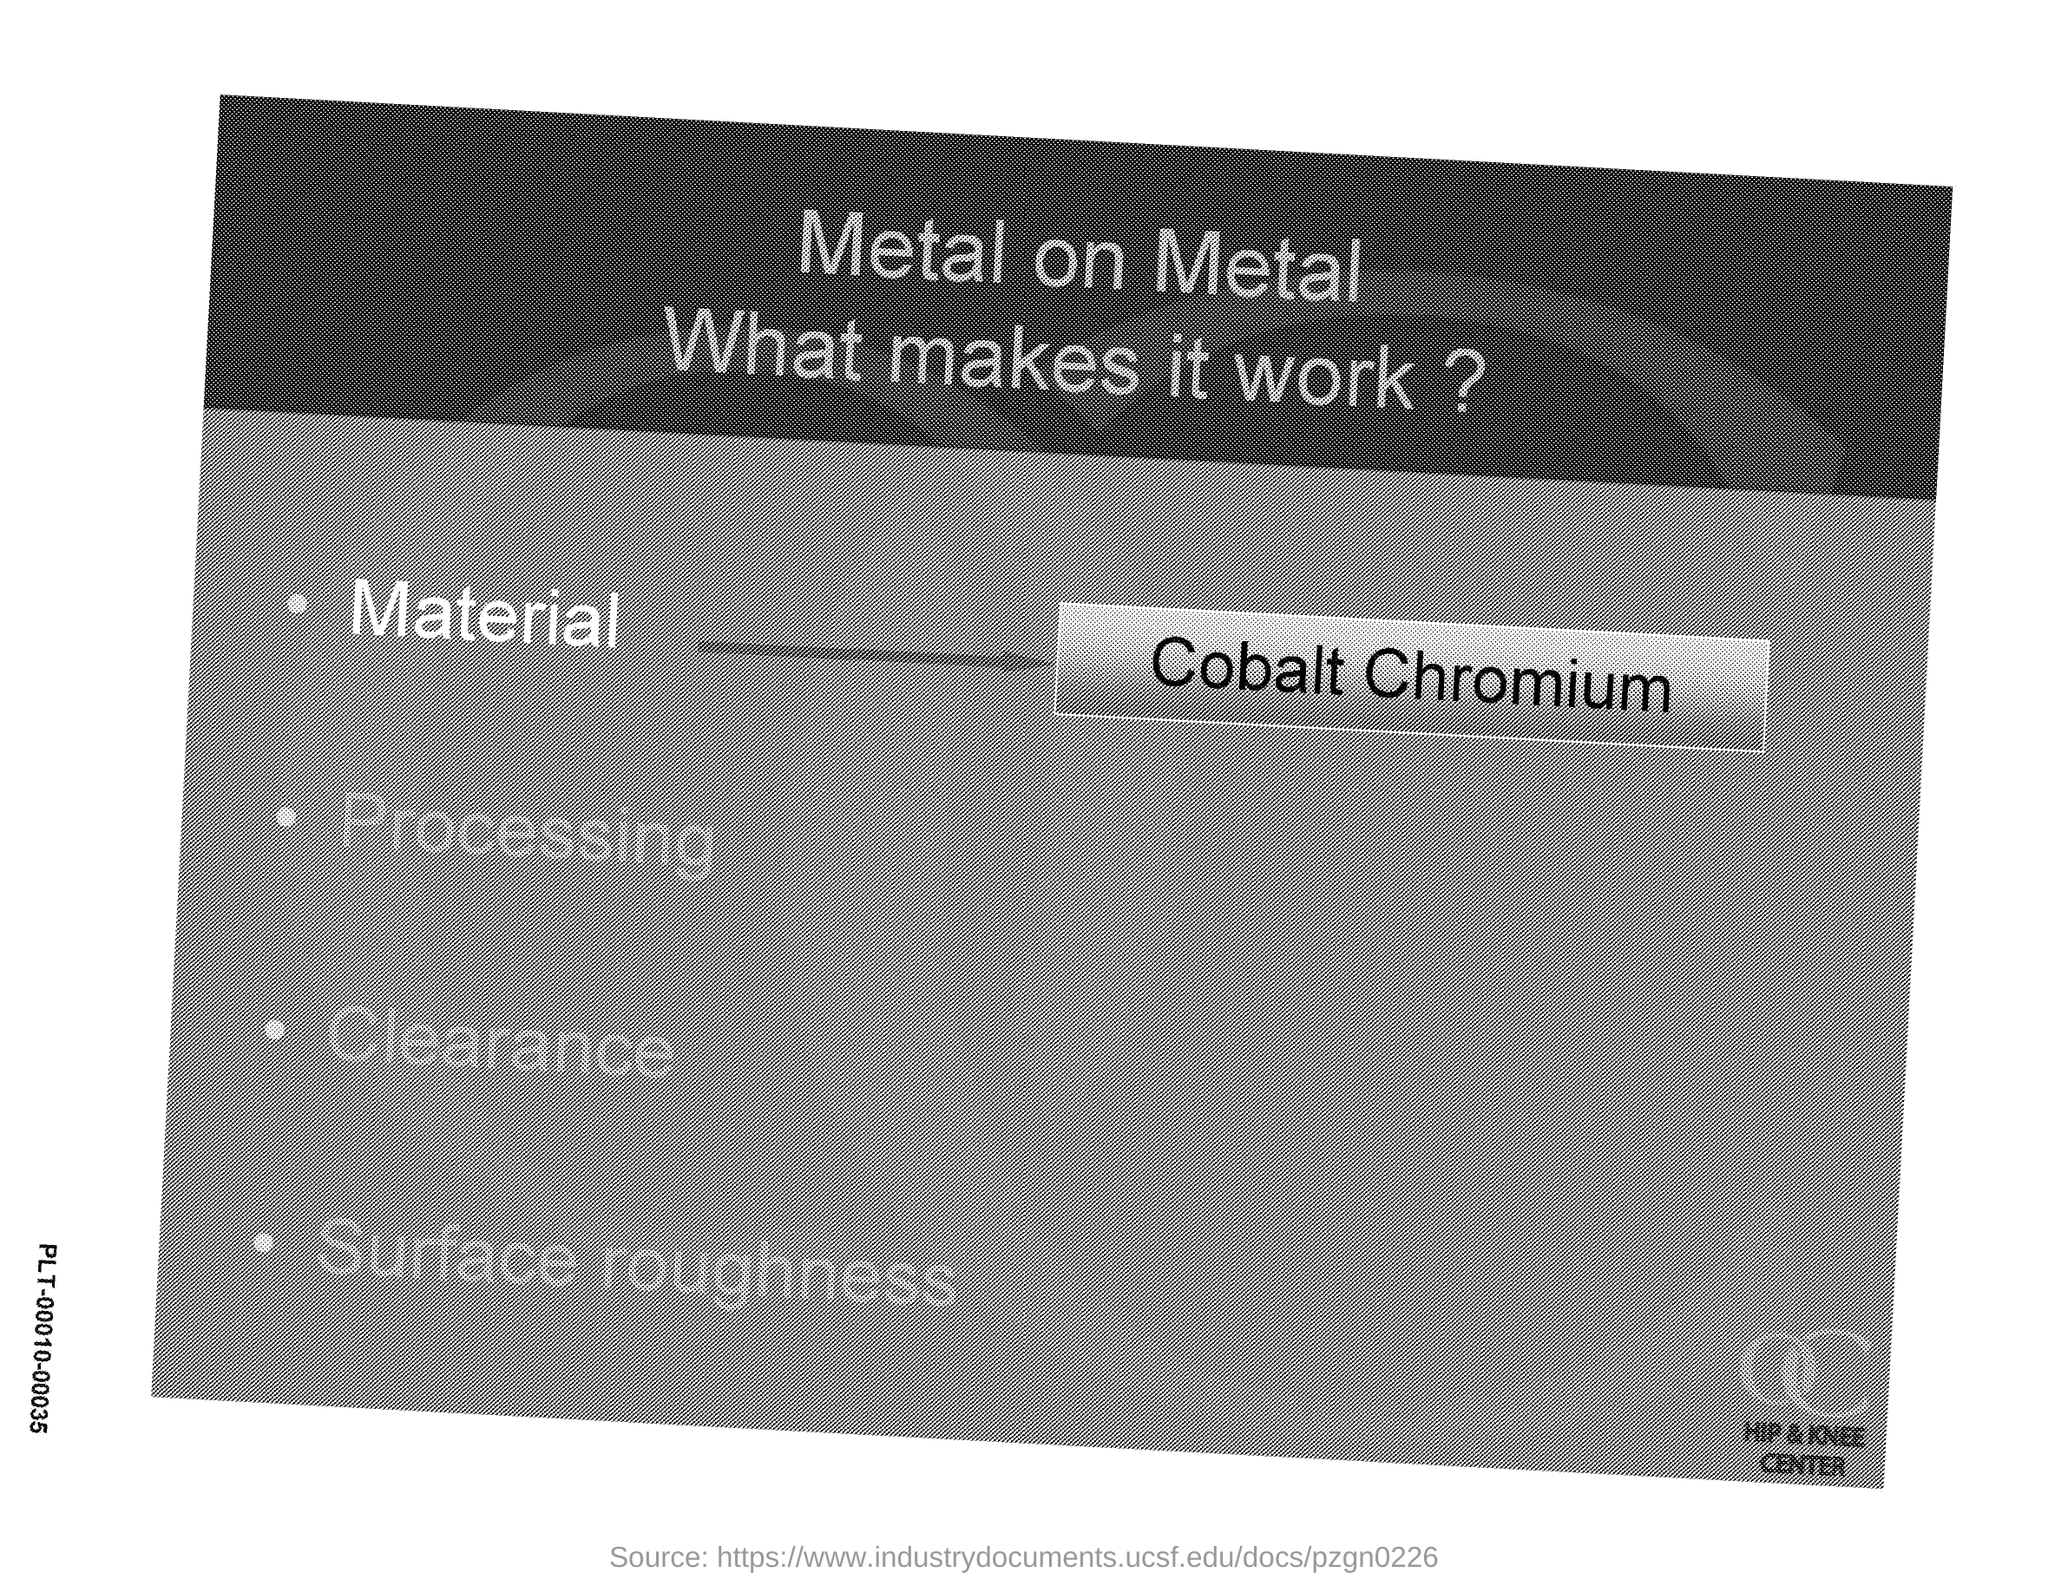What is the topic on ?
Keep it short and to the point. Metal on metal. What is the name of the material?
Keep it short and to the point. Cobalt Chromium. 